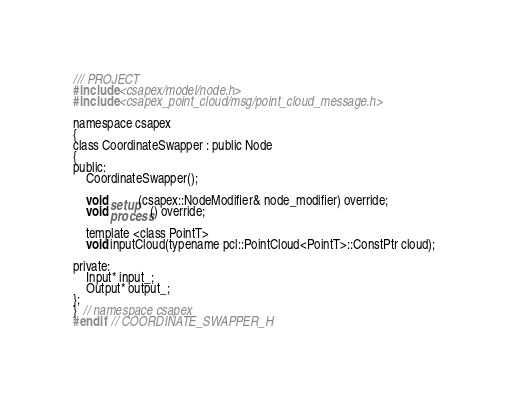Convert code to text. <code><loc_0><loc_0><loc_500><loc_500><_C_>/// PROJECT
#include <csapex/model/node.h>
#include <csapex_point_cloud/msg/point_cloud_message.h>

namespace csapex
{
class CoordinateSwapper : public Node
{
public:
    CoordinateSwapper();

    void setup(csapex::NodeModifier& node_modifier) override;
    void process() override;

    template <class PointT>
    void inputCloud(typename pcl::PointCloud<PointT>::ConstPtr cloud);

private:
    Input* input_;
    Output* output_;
};
}  // namespace csapex
#endif  // COORDINATE_SWAPPER_H
</code> 